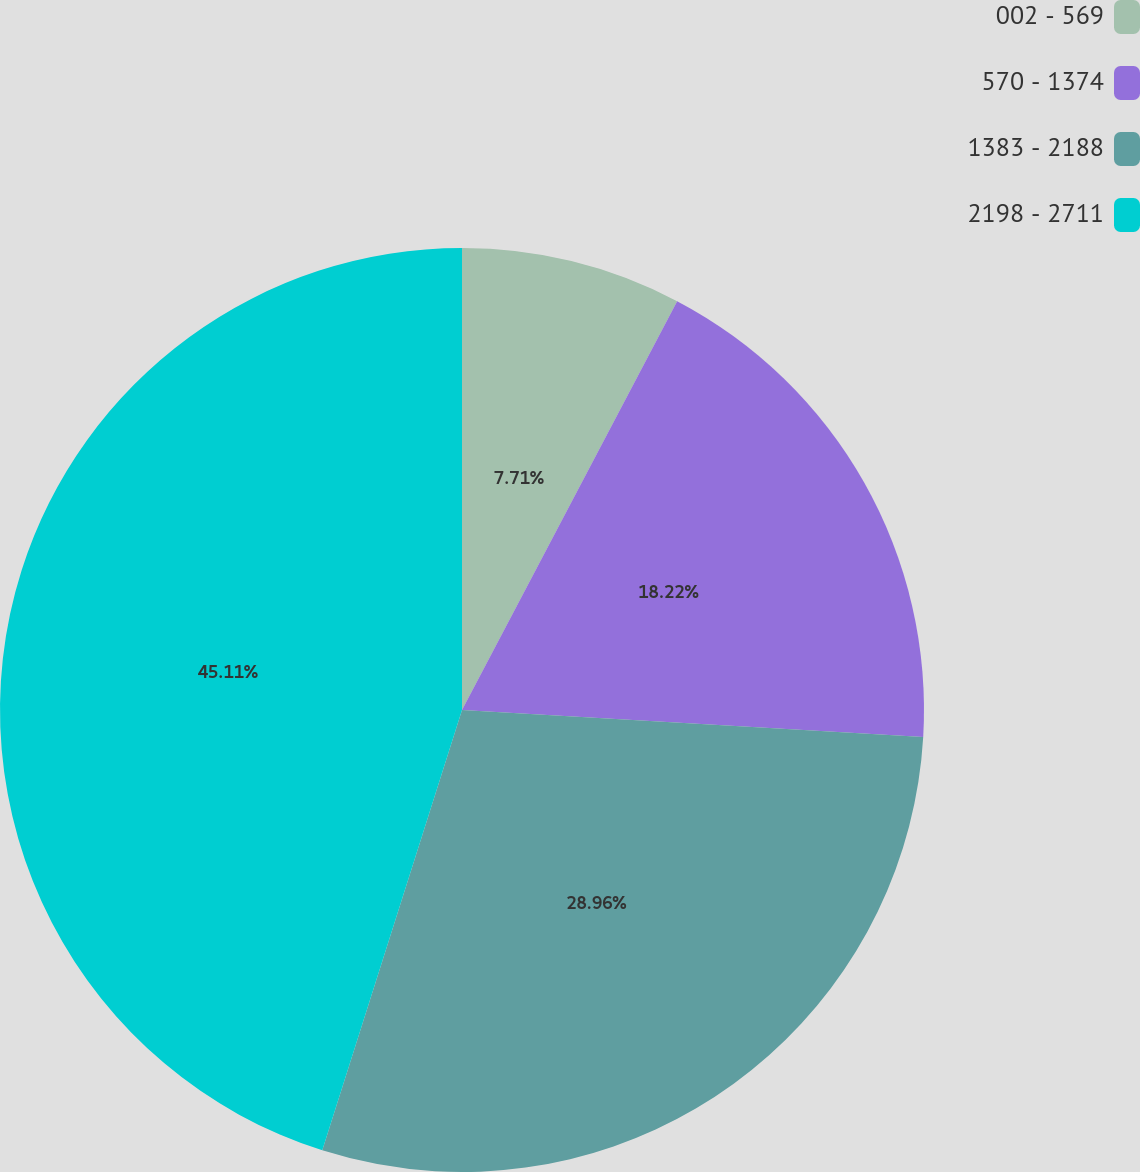Convert chart. <chart><loc_0><loc_0><loc_500><loc_500><pie_chart><fcel>002 - 569<fcel>570 - 1374<fcel>1383 - 2188<fcel>2198 - 2711<nl><fcel>7.71%<fcel>18.22%<fcel>28.96%<fcel>45.11%<nl></chart> 